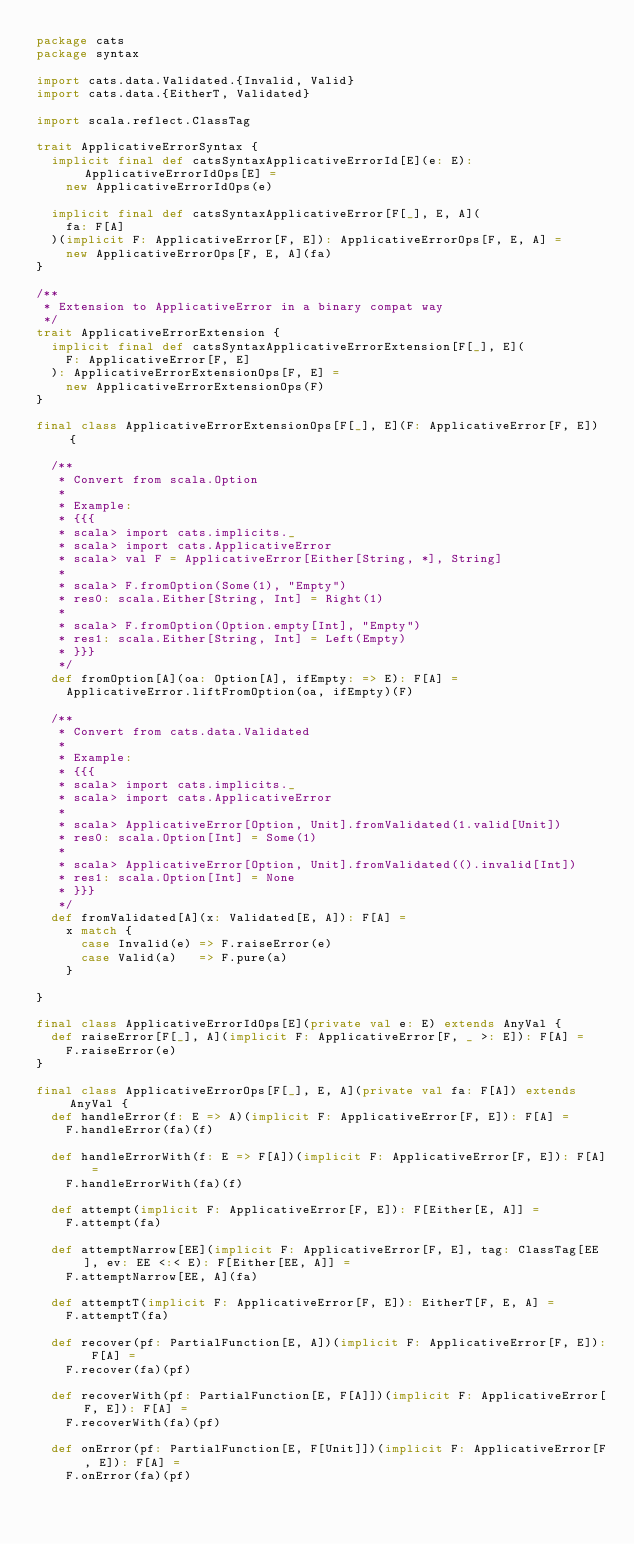Convert code to text. <code><loc_0><loc_0><loc_500><loc_500><_Scala_>package cats
package syntax

import cats.data.Validated.{Invalid, Valid}
import cats.data.{EitherT, Validated}

import scala.reflect.ClassTag

trait ApplicativeErrorSyntax {
  implicit final def catsSyntaxApplicativeErrorId[E](e: E): ApplicativeErrorIdOps[E] =
    new ApplicativeErrorIdOps(e)

  implicit final def catsSyntaxApplicativeError[F[_], E, A](
    fa: F[A]
  )(implicit F: ApplicativeError[F, E]): ApplicativeErrorOps[F, E, A] =
    new ApplicativeErrorOps[F, E, A](fa)
}

/**
 * Extension to ApplicativeError in a binary compat way
 */
trait ApplicativeErrorExtension {
  implicit final def catsSyntaxApplicativeErrorExtension[F[_], E](
    F: ApplicativeError[F, E]
  ): ApplicativeErrorExtensionOps[F, E] =
    new ApplicativeErrorExtensionOps(F)
}

final class ApplicativeErrorExtensionOps[F[_], E](F: ApplicativeError[F, E]) {

  /**
   * Convert from scala.Option
   *
   * Example:
   * {{{
   * scala> import cats.implicits._
   * scala> import cats.ApplicativeError
   * scala> val F = ApplicativeError[Either[String, *], String]
   *
   * scala> F.fromOption(Some(1), "Empty")
   * res0: scala.Either[String, Int] = Right(1)
   *
   * scala> F.fromOption(Option.empty[Int], "Empty")
   * res1: scala.Either[String, Int] = Left(Empty)
   * }}}
   */
  def fromOption[A](oa: Option[A], ifEmpty: => E): F[A] =
    ApplicativeError.liftFromOption(oa, ifEmpty)(F)

  /**
   * Convert from cats.data.Validated
   *
   * Example:
   * {{{
   * scala> import cats.implicits._
   * scala> import cats.ApplicativeError
   *
   * scala> ApplicativeError[Option, Unit].fromValidated(1.valid[Unit])
   * res0: scala.Option[Int] = Some(1)
   *
   * scala> ApplicativeError[Option, Unit].fromValidated(().invalid[Int])
   * res1: scala.Option[Int] = None
   * }}}
   */
  def fromValidated[A](x: Validated[E, A]): F[A] =
    x match {
      case Invalid(e) => F.raiseError(e)
      case Valid(a)   => F.pure(a)
    }

}

final class ApplicativeErrorIdOps[E](private val e: E) extends AnyVal {
  def raiseError[F[_], A](implicit F: ApplicativeError[F, _ >: E]): F[A] =
    F.raiseError(e)
}

final class ApplicativeErrorOps[F[_], E, A](private val fa: F[A]) extends AnyVal {
  def handleError(f: E => A)(implicit F: ApplicativeError[F, E]): F[A] =
    F.handleError(fa)(f)

  def handleErrorWith(f: E => F[A])(implicit F: ApplicativeError[F, E]): F[A] =
    F.handleErrorWith(fa)(f)

  def attempt(implicit F: ApplicativeError[F, E]): F[Either[E, A]] =
    F.attempt(fa)

  def attemptNarrow[EE](implicit F: ApplicativeError[F, E], tag: ClassTag[EE], ev: EE <:< E): F[Either[EE, A]] =
    F.attemptNarrow[EE, A](fa)

  def attemptT(implicit F: ApplicativeError[F, E]): EitherT[F, E, A] =
    F.attemptT(fa)

  def recover(pf: PartialFunction[E, A])(implicit F: ApplicativeError[F, E]): F[A] =
    F.recover(fa)(pf)

  def recoverWith(pf: PartialFunction[E, F[A]])(implicit F: ApplicativeError[F, E]): F[A] =
    F.recoverWith(fa)(pf)

  def onError(pf: PartialFunction[E, F[Unit]])(implicit F: ApplicativeError[F, E]): F[A] =
    F.onError(fa)(pf)
</code> 